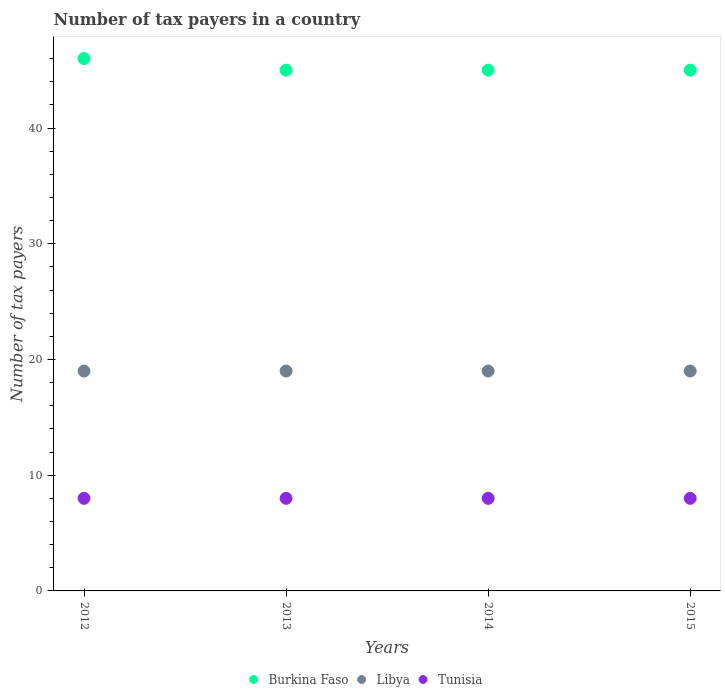Is the number of dotlines equal to the number of legend labels?
Offer a terse response. Yes. What is the number of tax payers in in Burkina Faso in 2015?
Provide a succinct answer. 45. Across all years, what is the maximum number of tax payers in in Burkina Faso?
Give a very brief answer. 46. Across all years, what is the minimum number of tax payers in in Burkina Faso?
Your response must be concise. 45. In which year was the number of tax payers in in Burkina Faso maximum?
Your response must be concise. 2012. What is the total number of tax payers in in Tunisia in the graph?
Give a very brief answer. 32. In the year 2013, what is the difference between the number of tax payers in in Libya and number of tax payers in in Burkina Faso?
Keep it short and to the point. -26. In how many years, is the number of tax payers in in Burkina Faso greater than 30?
Offer a terse response. 4. Is the difference between the number of tax payers in in Libya in 2014 and 2015 greater than the difference between the number of tax payers in in Burkina Faso in 2014 and 2015?
Your answer should be compact. No. What is the difference between the highest and the lowest number of tax payers in in Libya?
Give a very brief answer. 0. Is it the case that in every year, the sum of the number of tax payers in in Burkina Faso and number of tax payers in in Libya  is greater than the number of tax payers in in Tunisia?
Make the answer very short. Yes. Does the number of tax payers in in Tunisia monotonically increase over the years?
Your answer should be very brief. No. Does the graph contain any zero values?
Ensure brevity in your answer.  No. What is the title of the graph?
Offer a very short reply. Number of tax payers in a country. What is the label or title of the X-axis?
Provide a short and direct response. Years. What is the label or title of the Y-axis?
Your answer should be very brief. Number of tax payers. What is the Number of tax payers in Burkina Faso in 2012?
Ensure brevity in your answer.  46. What is the Number of tax payers of Libya in 2012?
Provide a short and direct response. 19. What is the Number of tax payers of Libya in 2013?
Give a very brief answer. 19. What is the Number of tax payers of Burkina Faso in 2014?
Your answer should be very brief. 45. What is the Number of tax payers of Tunisia in 2014?
Provide a succinct answer. 8. What is the Number of tax payers in Tunisia in 2015?
Your answer should be very brief. 8. Across all years, what is the maximum Number of tax payers in Tunisia?
Provide a short and direct response. 8. Across all years, what is the minimum Number of tax payers in Tunisia?
Your answer should be compact. 8. What is the total Number of tax payers of Burkina Faso in the graph?
Offer a very short reply. 181. What is the difference between the Number of tax payers of Burkina Faso in 2012 and that in 2013?
Ensure brevity in your answer.  1. What is the difference between the Number of tax payers in Tunisia in 2012 and that in 2013?
Provide a succinct answer. 0. What is the difference between the Number of tax payers in Burkina Faso in 2012 and that in 2014?
Provide a short and direct response. 1. What is the difference between the Number of tax payers of Burkina Faso in 2012 and that in 2015?
Your response must be concise. 1. What is the difference between the Number of tax payers in Libya in 2012 and that in 2015?
Offer a terse response. 0. What is the difference between the Number of tax payers of Tunisia in 2012 and that in 2015?
Give a very brief answer. 0. What is the difference between the Number of tax payers of Libya in 2013 and that in 2015?
Your answer should be very brief. 0. What is the difference between the Number of tax payers of Tunisia in 2013 and that in 2015?
Ensure brevity in your answer.  0. What is the difference between the Number of tax payers of Burkina Faso in 2014 and that in 2015?
Your answer should be very brief. 0. What is the difference between the Number of tax payers of Tunisia in 2014 and that in 2015?
Keep it short and to the point. 0. What is the difference between the Number of tax payers in Libya in 2012 and the Number of tax payers in Tunisia in 2013?
Your answer should be compact. 11. What is the difference between the Number of tax payers in Libya in 2012 and the Number of tax payers in Tunisia in 2014?
Keep it short and to the point. 11. What is the difference between the Number of tax payers of Burkina Faso in 2012 and the Number of tax payers of Libya in 2015?
Your response must be concise. 27. What is the difference between the Number of tax payers in Burkina Faso in 2012 and the Number of tax payers in Tunisia in 2015?
Offer a very short reply. 38. What is the difference between the Number of tax payers in Libya in 2012 and the Number of tax payers in Tunisia in 2015?
Offer a very short reply. 11. What is the difference between the Number of tax payers in Burkina Faso in 2013 and the Number of tax payers in Libya in 2014?
Your response must be concise. 26. What is the difference between the Number of tax payers of Burkina Faso in 2013 and the Number of tax payers of Tunisia in 2014?
Give a very brief answer. 37. What is the difference between the Number of tax payers in Libya in 2013 and the Number of tax payers in Tunisia in 2014?
Your answer should be compact. 11. What is the difference between the Number of tax payers of Burkina Faso in 2013 and the Number of tax payers of Libya in 2015?
Your response must be concise. 26. What is the difference between the Number of tax payers in Burkina Faso in 2013 and the Number of tax payers in Tunisia in 2015?
Make the answer very short. 37. What is the difference between the Number of tax payers in Libya in 2013 and the Number of tax payers in Tunisia in 2015?
Your response must be concise. 11. What is the difference between the Number of tax payers of Burkina Faso in 2014 and the Number of tax payers of Libya in 2015?
Your answer should be very brief. 26. What is the difference between the Number of tax payers of Libya in 2014 and the Number of tax payers of Tunisia in 2015?
Your answer should be very brief. 11. What is the average Number of tax payers of Burkina Faso per year?
Provide a short and direct response. 45.25. In the year 2012, what is the difference between the Number of tax payers in Burkina Faso and Number of tax payers in Libya?
Give a very brief answer. 27. In the year 2012, what is the difference between the Number of tax payers of Burkina Faso and Number of tax payers of Tunisia?
Your answer should be very brief. 38. In the year 2012, what is the difference between the Number of tax payers in Libya and Number of tax payers in Tunisia?
Keep it short and to the point. 11. In the year 2013, what is the difference between the Number of tax payers in Burkina Faso and Number of tax payers in Libya?
Offer a terse response. 26. In the year 2013, what is the difference between the Number of tax payers in Libya and Number of tax payers in Tunisia?
Offer a very short reply. 11. In the year 2014, what is the difference between the Number of tax payers in Libya and Number of tax payers in Tunisia?
Offer a terse response. 11. In the year 2015, what is the difference between the Number of tax payers in Burkina Faso and Number of tax payers in Libya?
Keep it short and to the point. 26. In the year 2015, what is the difference between the Number of tax payers in Burkina Faso and Number of tax payers in Tunisia?
Make the answer very short. 37. What is the ratio of the Number of tax payers in Burkina Faso in 2012 to that in 2013?
Ensure brevity in your answer.  1.02. What is the ratio of the Number of tax payers of Libya in 2012 to that in 2013?
Keep it short and to the point. 1. What is the ratio of the Number of tax payers of Burkina Faso in 2012 to that in 2014?
Offer a terse response. 1.02. What is the ratio of the Number of tax payers of Libya in 2012 to that in 2014?
Ensure brevity in your answer.  1. What is the ratio of the Number of tax payers of Tunisia in 2012 to that in 2014?
Provide a short and direct response. 1. What is the ratio of the Number of tax payers in Burkina Faso in 2012 to that in 2015?
Ensure brevity in your answer.  1.02. What is the ratio of the Number of tax payers of Libya in 2012 to that in 2015?
Make the answer very short. 1. What is the ratio of the Number of tax payers of Burkina Faso in 2013 to that in 2014?
Give a very brief answer. 1. What is the ratio of the Number of tax payers of Burkina Faso in 2013 to that in 2015?
Provide a short and direct response. 1. What is the ratio of the Number of tax payers in Tunisia in 2013 to that in 2015?
Your answer should be very brief. 1. What is the difference between the highest and the second highest Number of tax payers of Burkina Faso?
Your response must be concise. 1. What is the difference between the highest and the second highest Number of tax payers of Tunisia?
Offer a terse response. 0. What is the difference between the highest and the lowest Number of tax payers of Tunisia?
Offer a very short reply. 0. 